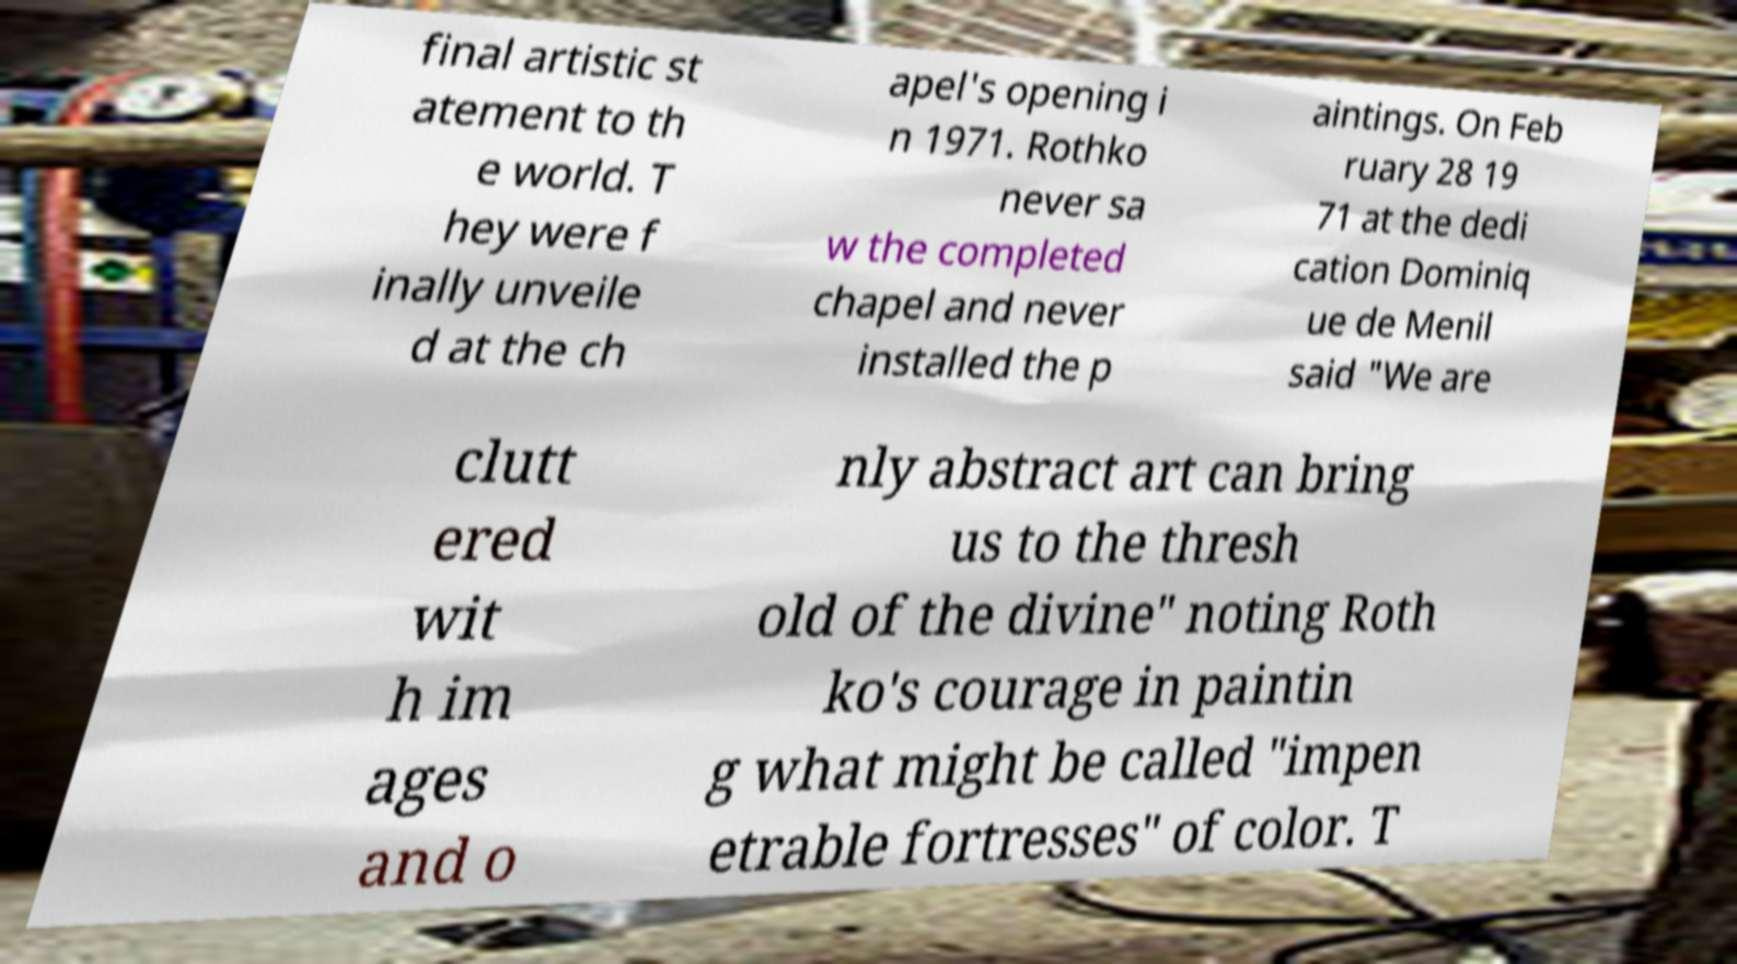Could you extract and type out the text from this image? final artistic st atement to th e world. T hey were f inally unveile d at the ch apel's opening i n 1971. Rothko never sa w the completed chapel and never installed the p aintings. On Feb ruary 28 19 71 at the dedi cation Dominiq ue de Menil said "We are clutt ered wit h im ages and o nly abstract art can bring us to the thresh old of the divine" noting Roth ko's courage in paintin g what might be called "impen etrable fortresses" of color. T 